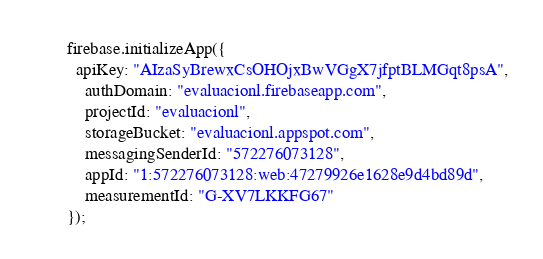<code> <loc_0><loc_0><loc_500><loc_500><_JavaScript_>

firebase.initializeApp({
  apiKey: "AIzaSyBrewxCsOHOjxBwVGgX7jfptBLMGqt8psA",
    authDomain: "evaluacionl.firebaseapp.com",
    projectId: "evaluacionl",
    storageBucket: "evaluacionl.appspot.com",
    messagingSenderId: "572276073128",
    appId: "1:572276073128:web:47279926e1628e9d4bd89d",
    measurementId: "G-XV7LKKFG67"
});
</code> 